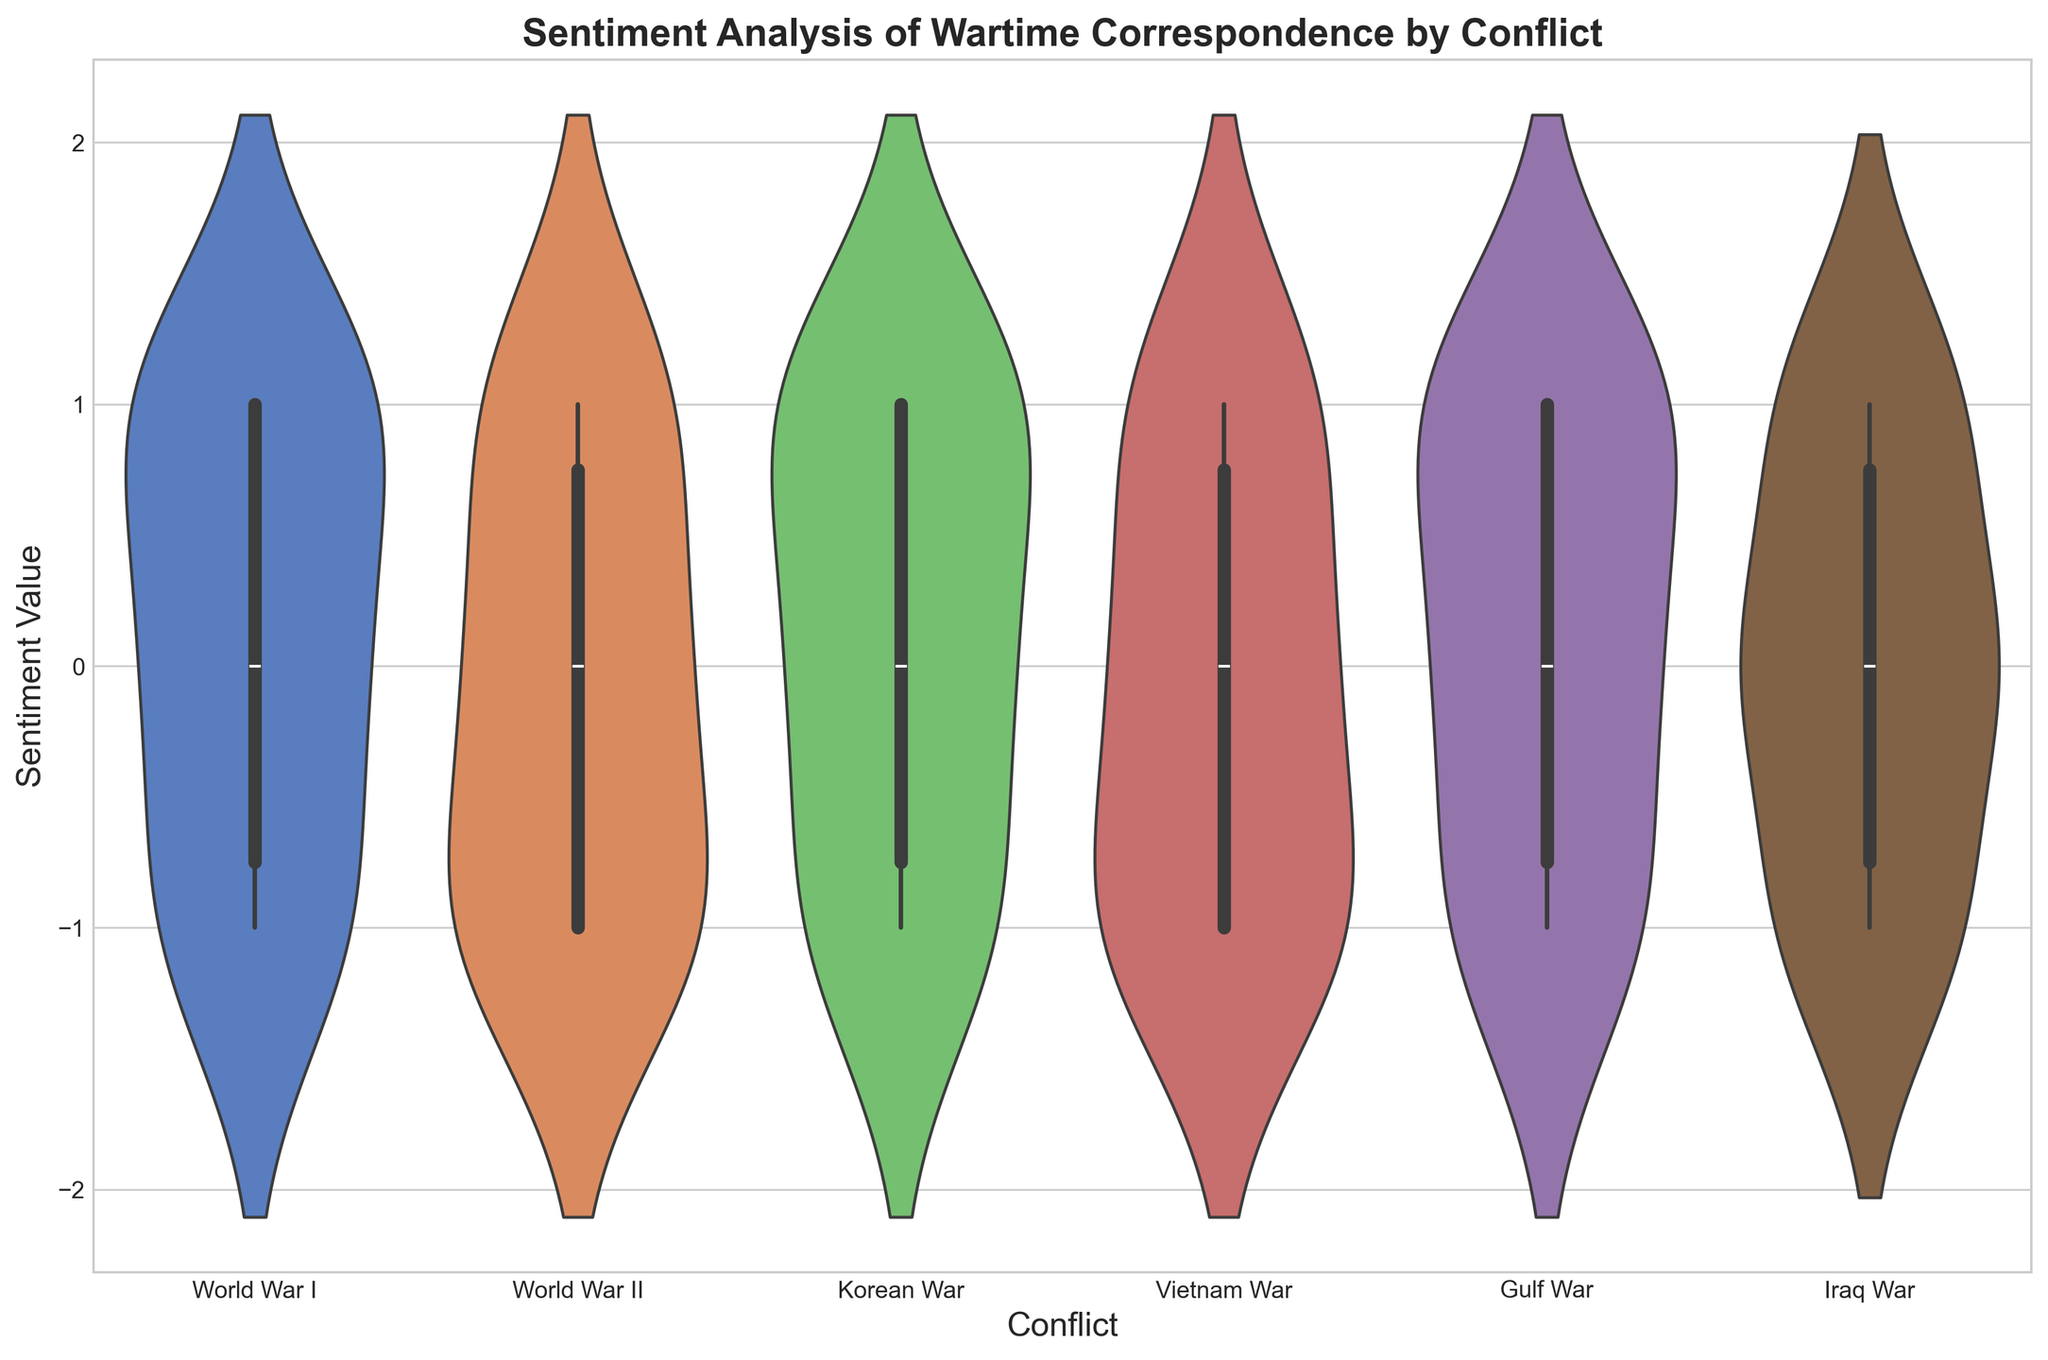Which conflict has the most positive sentiment in its wartime correspondence? The figure shows the distribution of sentiment values for each conflict. Look for the conflict where the distribution is skewed most towards the higher (positive) sentiment region.
Answer: World War I How does the sentiment during the Vietnam War compare to the Iraq War? Compare the distributions of sentiment values for the Vietnam War and the Iraq War. Notice the spread and where the most concentration of data points lies.
Answer: Vietnam War has a broader distribution, with equal representation in each sentiment What's the average sentiment value for World War II? Identify the median value of the sentiment distribution for World War II by observing where the central tendency lies along the vertical axis.
Answer: Approximately 0 Which conflict shows the greatest spread in sentiment values? Compare the range of the violin plots for each conflict and look for the widest spread from negative to positive sentiments.
Answer: Vietnam War Which has a higher median sentiment, Korean War or Gulf War? Locate the median points in the violin plots for both the Korean War and Gulf War. Compare which one lies higher on the sentiment axis.
Answer: Both are around 0 (neutral sentiment) In which conflict is negative sentiment least evident? Examine the distributions and look for the conflict whose violin plot has the least presence in negative values (bottom part of the plot).
Answer: World War I How many conflicts show an average neutral sentiment value? Count the conflicts whose median line appears closest to the neutral sentiment value (0).
Answer: Three Which conflict has the most neutral sentiment in its wartime correspondence? Identify the conflict where the distribution is skewed most towards the neutral (0) sentiment region.
Answer: Iraq War Compare the spread of sentiments in World War I and World War II Look at the spread in the violin plots; compare the overall range and the concentration of the data points for both conflicts.
Answer: World War II has a broader spread Which conflict exhibits the least variation in sentiment? Determine by observing which conflict's violin plot is the narrowest, indicating less deviation from the median value.
Answer: Gulf War 